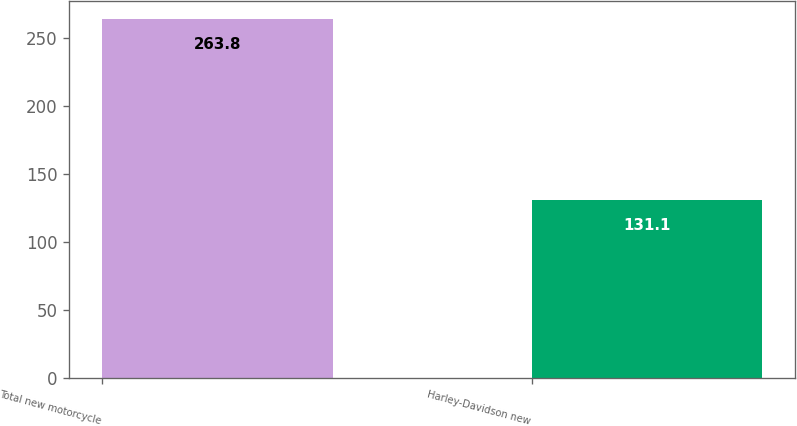Convert chart. <chart><loc_0><loc_0><loc_500><loc_500><bar_chart><fcel>Total new motorcycle<fcel>Harley-Davidson new<nl><fcel>263.8<fcel>131.1<nl></chart> 